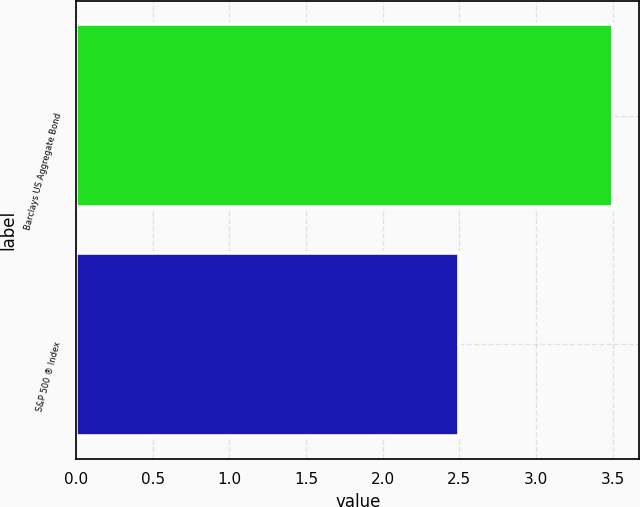Convert chart to OTSL. <chart><loc_0><loc_0><loc_500><loc_500><bar_chart><fcel>Barclays US Aggregate Bond<fcel>S&P 500 ® Index<nl><fcel>3.5<fcel>2.5<nl></chart> 